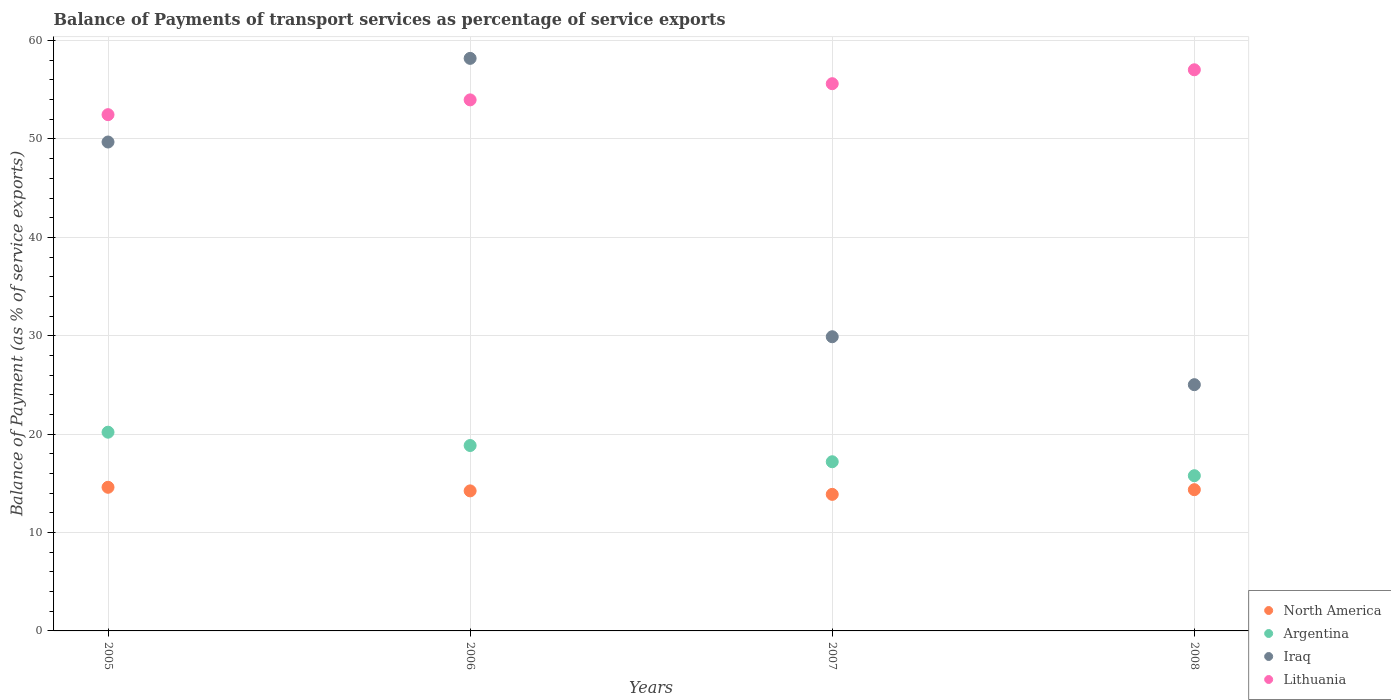What is the balance of payments of transport services in Iraq in 2006?
Keep it short and to the point. 58.19. Across all years, what is the maximum balance of payments of transport services in Iraq?
Offer a terse response. 58.19. Across all years, what is the minimum balance of payments of transport services in Argentina?
Ensure brevity in your answer.  15.78. In which year was the balance of payments of transport services in Argentina maximum?
Ensure brevity in your answer.  2005. In which year was the balance of payments of transport services in Iraq minimum?
Ensure brevity in your answer.  2008. What is the total balance of payments of transport services in North America in the graph?
Make the answer very short. 57.06. What is the difference between the balance of payments of transport services in Iraq in 2005 and that in 2008?
Give a very brief answer. 24.66. What is the difference between the balance of payments of transport services in North America in 2006 and the balance of payments of transport services in Lithuania in 2007?
Your answer should be very brief. -41.38. What is the average balance of payments of transport services in Lithuania per year?
Your answer should be very brief. 54.77. In the year 2007, what is the difference between the balance of payments of transport services in North America and balance of payments of transport services in Iraq?
Provide a short and direct response. -16.02. What is the ratio of the balance of payments of transport services in Argentina in 2006 to that in 2008?
Keep it short and to the point. 1.19. Is the balance of payments of transport services in Argentina in 2005 less than that in 2008?
Ensure brevity in your answer.  No. Is the difference between the balance of payments of transport services in North America in 2005 and 2008 greater than the difference between the balance of payments of transport services in Iraq in 2005 and 2008?
Make the answer very short. No. What is the difference between the highest and the second highest balance of payments of transport services in North America?
Make the answer very short. 0.24. What is the difference between the highest and the lowest balance of payments of transport services in North America?
Provide a short and direct response. 0.72. Is it the case that in every year, the sum of the balance of payments of transport services in Argentina and balance of payments of transport services in Iraq  is greater than the balance of payments of transport services in North America?
Offer a very short reply. Yes. Is the balance of payments of transport services in Iraq strictly greater than the balance of payments of transport services in North America over the years?
Provide a short and direct response. Yes. Is the balance of payments of transport services in Iraq strictly less than the balance of payments of transport services in Lithuania over the years?
Provide a short and direct response. No. Are the values on the major ticks of Y-axis written in scientific E-notation?
Give a very brief answer. No. Does the graph contain any zero values?
Make the answer very short. No. How are the legend labels stacked?
Provide a short and direct response. Vertical. What is the title of the graph?
Offer a very short reply. Balance of Payments of transport services as percentage of service exports. What is the label or title of the X-axis?
Give a very brief answer. Years. What is the label or title of the Y-axis?
Offer a very short reply. Balance of Payment (as % of service exports). What is the Balance of Payment (as % of service exports) in North America in 2005?
Provide a short and direct response. 14.6. What is the Balance of Payment (as % of service exports) of Argentina in 2005?
Your answer should be compact. 20.2. What is the Balance of Payment (as % of service exports) in Iraq in 2005?
Your response must be concise. 49.69. What is the Balance of Payment (as % of service exports) of Lithuania in 2005?
Your response must be concise. 52.47. What is the Balance of Payment (as % of service exports) in North America in 2006?
Your answer should be compact. 14.23. What is the Balance of Payment (as % of service exports) in Argentina in 2006?
Your answer should be very brief. 18.84. What is the Balance of Payment (as % of service exports) in Iraq in 2006?
Your answer should be very brief. 58.19. What is the Balance of Payment (as % of service exports) of Lithuania in 2006?
Keep it short and to the point. 53.97. What is the Balance of Payment (as % of service exports) in North America in 2007?
Provide a short and direct response. 13.88. What is the Balance of Payment (as % of service exports) of Argentina in 2007?
Keep it short and to the point. 17.19. What is the Balance of Payment (as % of service exports) in Iraq in 2007?
Keep it short and to the point. 29.9. What is the Balance of Payment (as % of service exports) of Lithuania in 2007?
Give a very brief answer. 55.62. What is the Balance of Payment (as % of service exports) in North America in 2008?
Offer a terse response. 14.35. What is the Balance of Payment (as % of service exports) in Argentina in 2008?
Offer a terse response. 15.78. What is the Balance of Payment (as % of service exports) of Iraq in 2008?
Provide a succinct answer. 25.03. What is the Balance of Payment (as % of service exports) in Lithuania in 2008?
Give a very brief answer. 57.03. Across all years, what is the maximum Balance of Payment (as % of service exports) of North America?
Make the answer very short. 14.6. Across all years, what is the maximum Balance of Payment (as % of service exports) of Argentina?
Give a very brief answer. 20.2. Across all years, what is the maximum Balance of Payment (as % of service exports) in Iraq?
Your response must be concise. 58.19. Across all years, what is the maximum Balance of Payment (as % of service exports) in Lithuania?
Give a very brief answer. 57.03. Across all years, what is the minimum Balance of Payment (as % of service exports) in North America?
Provide a succinct answer. 13.88. Across all years, what is the minimum Balance of Payment (as % of service exports) in Argentina?
Keep it short and to the point. 15.78. Across all years, what is the minimum Balance of Payment (as % of service exports) in Iraq?
Provide a short and direct response. 25.03. Across all years, what is the minimum Balance of Payment (as % of service exports) in Lithuania?
Offer a very short reply. 52.47. What is the total Balance of Payment (as % of service exports) of North America in the graph?
Your response must be concise. 57.06. What is the total Balance of Payment (as % of service exports) of Argentina in the graph?
Your answer should be very brief. 72.01. What is the total Balance of Payment (as % of service exports) of Iraq in the graph?
Your answer should be very brief. 162.81. What is the total Balance of Payment (as % of service exports) of Lithuania in the graph?
Offer a terse response. 219.09. What is the difference between the Balance of Payment (as % of service exports) in North America in 2005 and that in 2006?
Your answer should be very brief. 0.37. What is the difference between the Balance of Payment (as % of service exports) of Argentina in 2005 and that in 2006?
Provide a short and direct response. 1.35. What is the difference between the Balance of Payment (as % of service exports) in Iraq in 2005 and that in 2006?
Keep it short and to the point. -8.5. What is the difference between the Balance of Payment (as % of service exports) in Lithuania in 2005 and that in 2006?
Make the answer very short. -1.5. What is the difference between the Balance of Payment (as % of service exports) in North America in 2005 and that in 2007?
Offer a very short reply. 0.72. What is the difference between the Balance of Payment (as % of service exports) of Argentina in 2005 and that in 2007?
Provide a succinct answer. 3. What is the difference between the Balance of Payment (as % of service exports) of Iraq in 2005 and that in 2007?
Your answer should be very brief. 19.79. What is the difference between the Balance of Payment (as % of service exports) of Lithuania in 2005 and that in 2007?
Ensure brevity in your answer.  -3.15. What is the difference between the Balance of Payment (as % of service exports) in North America in 2005 and that in 2008?
Make the answer very short. 0.24. What is the difference between the Balance of Payment (as % of service exports) in Argentina in 2005 and that in 2008?
Your answer should be very brief. 4.42. What is the difference between the Balance of Payment (as % of service exports) of Iraq in 2005 and that in 2008?
Provide a short and direct response. 24.66. What is the difference between the Balance of Payment (as % of service exports) in Lithuania in 2005 and that in 2008?
Offer a terse response. -4.56. What is the difference between the Balance of Payment (as % of service exports) of North America in 2006 and that in 2007?
Provide a short and direct response. 0.35. What is the difference between the Balance of Payment (as % of service exports) of Argentina in 2006 and that in 2007?
Your response must be concise. 1.65. What is the difference between the Balance of Payment (as % of service exports) in Iraq in 2006 and that in 2007?
Give a very brief answer. 28.29. What is the difference between the Balance of Payment (as % of service exports) of Lithuania in 2006 and that in 2007?
Provide a succinct answer. -1.64. What is the difference between the Balance of Payment (as % of service exports) in North America in 2006 and that in 2008?
Make the answer very short. -0.12. What is the difference between the Balance of Payment (as % of service exports) in Argentina in 2006 and that in 2008?
Provide a short and direct response. 3.07. What is the difference between the Balance of Payment (as % of service exports) in Iraq in 2006 and that in 2008?
Your answer should be compact. 33.16. What is the difference between the Balance of Payment (as % of service exports) in Lithuania in 2006 and that in 2008?
Keep it short and to the point. -3.06. What is the difference between the Balance of Payment (as % of service exports) in North America in 2007 and that in 2008?
Your answer should be very brief. -0.48. What is the difference between the Balance of Payment (as % of service exports) of Argentina in 2007 and that in 2008?
Your answer should be very brief. 1.42. What is the difference between the Balance of Payment (as % of service exports) in Iraq in 2007 and that in 2008?
Your answer should be very brief. 4.87. What is the difference between the Balance of Payment (as % of service exports) of Lithuania in 2007 and that in 2008?
Provide a succinct answer. -1.41. What is the difference between the Balance of Payment (as % of service exports) of North America in 2005 and the Balance of Payment (as % of service exports) of Argentina in 2006?
Offer a terse response. -4.24. What is the difference between the Balance of Payment (as % of service exports) in North America in 2005 and the Balance of Payment (as % of service exports) in Iraq in 2006?
Ensure brevity in your answer.  -43.59. What is the difference between the Balance of Payment (as % of service exports) in North America in 2005 and the Balance of Payment (as % of service exports) in Lithuania in 2006?
Make the answer very short. -39.37. What is the difference between the Balance of Payment (as % of service exports) of Argentina in 2005 and the Balance of Payment (as % of service exports) of Iraq in 2006?
Offer a very short reply. -37.99. What is the difference between the Balance of Payment (as % of service exports) of Argentina in 2005 and the Balance of Payment (as % of service exports) of Lithuania in 2006?
Offer a very short reply. -33.77. What is the difference between the Balance of Payment (as % of service exports) of Iraq in 2005 and the Balance of Payment (as % of service exports) of Lithuania in 2006?
Your answer should be very brief. -4.28. What is the difference between the Balance of Payment (as % of service exports) of North America in 2005 and the Balance of Payment (as % of service exports) of Argentina in 2007?
Give a very brief answer. -2.6. What is the difference between the Balance of Payment (as % of service exports) in North America in 2005 and the Balance of Payment (as % of service exports) in Iraq in 2007?
Keep it short and to the point. -15.3. What is the difference between the Balance of Payment (as % of service exports) of North America in 2005 and the Balance of Payment (as % of service exports) of Lithuania in 2007?
Provide a succinct answer. -41.02. What is the difference between the Balance of Payment (as % of service exports) in Argentina in 2005 and the Balance of Payment (as % of service exports) in Iraq in 2007?
Make the answer very short. -9.7. What is the difference between the Balance of Payment (as % of service exports) of Argentina in 2005 and the Balance of Payment (as % of service exports) of Lithuania in 2007?
Provide a short and direct response. -35.42. What is the difference between the Balance of Payment (as % of service exports) of Iraq in 2005 and the Balance of Payment (as % of service exports) of Lithuania in 2007?
Offer a very short reply. -5.93. What is the difference between the Balance of Payment (as % of service exports) in North America in 2005 and the Balance of Payment (as % of service exports) in Argentina in 2008?
Offer a terse response. -1.18. What is the difference between the Balance of Payment (as % of service exports) of North America in 2005 and the Balance of Payment (as % of service exports) of Iraq in 2008?
Provide a succinct answer. -10.43. What is the difference between the Balance of Payment (as % of service exports) of North America in 2005 and the Balance of Payment (as % of service exports) of Lithuania in 2008?
Keep it short and to the point. -42.43. What is the difference between the Balance of Payment (as % of service exports) in Argentina in 2005 and the Balance of Payment (as % of service exports) in Iraq in 2008?
Your answer should be compact. -4.83. What is the difference between the Balance of Payment (as % of service exports) in Argentina in 2005 and the Balance of Payment (as % of service exports) in Lithuania in 2008?
Offer a terse response. -36.83. What is the difference between the Balance of Payment (as % of service exports) in Iraq in 2005 and the Balance of Payment (as % of service exports) in Lithuania in 2008?
Your answer should be compact. -7.34. What is the difference between the Balance of Payment (as % of service exports) of North America in 2006 and the Balance of Payment (as % of service exports) of Argentina in 2007?
Your response must be concise. -2.96. What is the difference between the Balance of Payment (as % of service exports) of North America in 2006 and the Balance of Payment (as % of service exports) of Iraq in 2007?
Offer a terse response. -15.67. What is the difference between the Balance of Payment (as % of service exports) of North America in 2006 and the Balance of Payment (as % of service exports) of Lithuania in 2007?
Keep it short and to the point. -41.38. What is the difference between the Balance of Payment (as % of service exports) in Argentina in 2006 and the Balance of Payment (as % of service exports) in Iraq in 2007?
Your answer should be compact. -11.06. What is the difference between the Balance of Payment (as % of service exports) of Argentina in 2006 and the Balance of Payment (as % of service exports) of Lithuania in 2007?
Make the answer very short. -36.77. What is the difference between the Balance of Payment (as % of service exports) of Iraq in 2006 and the Balance of Payment (as % of service exports) of Lithuania in 2007?
Offer a terse response. 2.57. What is the difference between the Balance of Payment (as % of service exports) of North America in 2006 and the Balance of Payment (as % of service exports) of Argentina in 2008?
Keep it short and to the point. -1.54. What is the difference between the Balance of Payment (as % of service exports) of North America in 2006 and the Balance of Payment (as % of service exports) of Iraq in 2008?
Offer a very short reply. -10.79. What is the difference between the Balance of Payment (as % of service exports) in North America in 2006 and the Balance of Payment (as % of service exports) in Lithuania in 2008?
Give a very brief answer. -42.8. What is the difference between the Balance of Payment (as % of service exports) of Argentina in 2006 and the Balance of Payment (as % of service exports) of Iraq in 2008?
Give a very brief answer. -6.18. What is the difference between the Balance of Payment (as % of service exports) of Argentina in 2006 and the Balance of Payment (as % of service exports) of Lithuania in 2008?
Offer a terse response. -38.19. What is the difference between the Balance of Payment (as % of service exports) of Iraq in 2006 and the Balance of Payment (as % of service exports) of Lithuania in 2008?
Offer a very short reply. 1.16. What is the difference between the Balance of Payment (as % of service exports) in North America in 2007 and the Balance of Payment (as % of service exports) in Argentina in 2008?
Keep it short and to the point. -1.9. What is the difference between the Balance of Payment (as % of service exports) of North America in 2007 and the Balance of Payment (as % of service exports) of Iraq in 2008?
Offer a very short reply. -11.15. What is the difference between the Balance of Payment (as % of service exports) in North America in 2007 and the Balance of Payment (as % of service exports) in Lithuania in 2008?
Keep it short and to the point. -43.15. What is the difference between the Balance of Payment (as % of service exports) of Argentina in 2007 and the Balance of Payment (as % of service exports) of Iraq in 2008?
Provide a short and direct response. -7.83. What is the difference between the Balance of Payment (as % of service exports) of Argentina in 2007 and the Balance of Payment (as % of service exports) of Lithuania in 2008?
Your answer should be very brief. -39.84. What is the difference between the Balance of Payment (as % of service exports) in Iraq in 2007 and the Balance of Payment (as % of service exports) in Lithuania in 2008?
Offer a very short reply. -27.13. What is the average Balance of Payment (as % of service exports) of North America per year?
Provide a succinct answer. 14.27. What is the average Balance of Payment (as % of service exports) of Argentina per year?
Offer a terse response. 18. What is the average Balance of Payment (as % of service exports) in Iraq per year?
Offer a terse response. 40.7. What is the average Balance of Payment (as % of service exports) of Lithuania per year?
Give a very brief answer. 54.77. In the year 2005, what is the difference between the Balance of Payment (as % of service exports) in North America and Balance of Payment (as % of service exports) in Argentina?
Ensure brevity in your answer.  -5.6. In the year 2005, what is the difference between the Balance of Payment (as % of service exports) in North America and Balance of Payment (as % of service exports) in Iraq?
Your answer should be compact. -35.09. In the year 2005, what is the difference between the Balance of Payment (as % of service exports) in North America and Balance of Payment (as % of service exports) in Lithuania?
Offer a terse response. -37.87. In the year 2005, what is the difference between the Balance of Payment (as % of service exports) in Argentina and Balance of Payment (as % of service exports) in Iraq?
Provide a short and direct response. -29.49. In the year 2005, what is the difference between the Balance of Payment (as % of service exports) in Argentina and Balance of Payment (as % of service exports) in Lithuania?
Your response must be concise. -32.27. In the year 2005, what is the difference between the Balance of Payment (as % of service exports) of Iraq and Balance of Payment (as % of service exports) of Lithuania?
Your response must be concise. -2.78. In the year 2006, what is the difference between the Balance of Payment (as % of service exports) of North America and Balance of Payment (as % of service exports) of Argentina?
Your response must be concise. -4.61. In the year 2006, what is the difference between the Balance of Payment (as % of service exports) in North America and Balance of Payment (as % of service exports) in Iraq?
Offer a very short reply. -43.96. In the year 2006, what is the difference between the Balance of Payment (as % of service exports) in North America and Balance of Payment (as % of service exports) in Lithuania?
Offer a terse response. -39.74. In the year 2006, what is the difference between the Balance of Payment (as % of service exports) of Argentina and Balance of Payment (as % of service exports) of Iraq?
Keep it short and to the point. -39.35. In the year 2006, what is the difference between the Balance of Payment (as % of service exports) of Argentina and Balance of Payment (as % of service exports) of Lithuania?
Provide a succinct answer. -35.13. In the year 2006, what is the difference between the Balance of Payment (as % of service exports) of Iraq and Balance of Payment (as % of service exports) of Lithuania?
Give a very brief answer. 4.22. In the year 2007, what is the difference between the Balance of Payment (as % of service exports) in North America and Balance of Payment (as % of service exports) in Argentina?
Keep it short and to the point. -3.32. In the year 2007, what is the difference between the Balance of Payment (as % of service exports) in North America and Balance of Payment (as % of service exports) in Iraq?
Offer a terse response. -16.02. In the year 2007, what is the difference between the Balance of Payment (as % of service exports) of North America and Balance of Payment (as % of service exports) of Lithuania?
Ensure brevity in your answer.  -41.74. In the year 2007, what is the difference between the Balance of Payment (as % of service exports) of Argentina and Balance of Payment (as % of service exports) of Iraq?
Your answer should be very brief. -12.71. In the year 2007, what is the difference between the Balance of Payment (as % of service exports) of Argentina and Balance of Payment (as % of service exports) of Lithuania?
Make the answer very short. -38.42. In the year 2007, what is the difference between the Balance of Payment (as % of service exports) of Iraq and Balance of Payment (as % of service exports) of Lithuania?
Make the answer very short. -25.72. In the year 2008, what is the difference between the Balance of Payment (as % of service exports) in North America and Balance of Payment (as % of service exports) in Argentina?
Provide a short and direct response. -1.42. In the year 2008, what is the difference between the Balance of Payment (as % of service exports) of North America and Balance of Payment (as % of service exports) of Iraq?
Your answer should be very brief. -10.67. In the year 2008, what is the difference between the Balance of Payment (as % of service exports) of North America and Balance of Payment (as % of service exports) of Lithuania?
Ensure brevity in your answer.  -42.68. In the year 2008, what is the difference between the Balance of Payment (as % of service exports) of Argentina and Balance of Payment (as % of service exports) of Iraq?
Ensure brevity in your answer.  -9.25. In the year 2008, what is the difference between the Balance of Payment (as % of service exports) in Argentina and Balance of Payment (as % of service exports) in Lithuania?
Your answer should be very brief. -41.26. In the year 2008, what is the difference between the Balance of Payment (as % of service exports) in Iraq and Balance of Payment (as % of service exports) in Lithuania?
Offer a very short reply. -32.01. What is the ratio of the Balance of Payment (as % of service exports) in North America in 2005 to that in 2006?
Provide a succinct answer. 1.03. What is the ratio of the Balance of Payment (as % of service exports) in Argentina in 2005 to that in 2006?
Provide a succinct answer. 1.07. What is the ratio of the Balance of Payment (as % of service exports) in Iraq in 2005 to that in 2006?
Your response must be concise. 0.85. What is the ratio of the Balance of Payment (as % of service exports) in Lithuania in 2005 to that in 2006?
Provide a succinct answer. 0.97. What is the ratio of the Balance of Payment (as % of service exports) of North America in 2005 to that in 2007?
Provide a succinct answer. 1.05. What is the ratio of the Balance of Payment (as % of service exports) in Argentina in 2005 to that in 2007?
Provide a short and direct response. 1.17. What is the ratio of the Balance of Payment (as % of service exports) of Iraq in 2005 to that in 2007?
Provide a succinct answer. 1.66. What is the ratio of the Balance of Payment (as % of service exports) in Lithuania in 2005 to that in 2007?
Provide a short and direct response. 0.94. What is the ratio of the Balance of Payment (as % of service exports) of North America in 2005 to that in 2008?
Provide a short and direct response. 1.02. What is the ratio of the Balance of Payment (as % of service exports) in Argentina in 2005 to that in 2008?
Provide a succinct answer. 1.28. What is the ratio of the Balance of Payment (as % of service exports) of Iraq in 2005 to that in 2008?
Keep it short and to the point. 1.99. What is the ratio of the Balance of Payment (as % of service exports) in North America in 2006 to that in 2007?
Provide a succinct answer. 1.03. What is the ratio of the Balance of Payment (as % of service exports) in Argentina in 2006 to that in 2007?
Provide a short and direct response. 1.1. What is the ratio of the Balance of Payment (as % of service exports) in Iraq in 2006 to that in 2007?
Provide a succinct answer. 1.95. What is the ratio of the Balance of Payment (as % of service exports) in Lithuania in 2006 to that in 2007?
Offer a terse response. 0.97. What is the ratio of the Balance of Payment (as % of service exports) in Argentina in 2006 to that in 2008?
Provide a succinct answer. 1.19. What is the ratio of the Balance of Payment (as % of service exports) of Iraq in 2006 to that in 2008?
Provide a succinct answer. 2.33. What is the ratio of the Balance of Payment (as % of service exports) in Lithuania in 2006 to that in 2008?
Keep it short and to the point. 0.95. What is the ratio of the Balance of Payment (as % of service exports) of North America in 2007 to that in 2008?
Keep it short and to the point. 0.97. What is the ratio of the Balance of Payment (as % of service exports) of Argentina in 2007 to that in 2008?
Provide a short and direct response. 1.09. What is the ratio of the Balance of Payment (as % of service exports) of Iraq in 2007 to that in 2008?
Give a very brief answer. 1.19. What is the ratio of the Balance of Payment (as % of service exports) in Lithuania in 2007 to that in 2008?
Your answer should be very brief. 0.98. What is the difference between the highest and the second highest Balance of Payment (as % of service exports) in North America?
Your answer should be very brief. 0.24. What is the difference between the highest and the second highest Balance of Payment (as % of service exports) of Argentina?
Provide a short and direct response. 1.35. What is the difference between the highest and the second highest Balance of Payment (as % of service exports) in Iraq?
Give a very brief answer. 8.5. What is the difference between the highest and the second highest Balance of Payment (as % of service exports) in Lithuania?
Offer a very short reply. 1.41. What is the difference between the highest and the lowest Balance of Payment (as % of service exports) in North America?
Your answer should be compact. 0.72. What is the difference between the highest and the lowest Balance of Payment (as % of service exports) in Argentina?
Provide a succinct answer. 4.42. What is the difference between the highest and the lowest Balance of Payment (as % of service exports) of Iraq?
Your answer should be very brief. 33.16. What is the difference between the highest and the lowest Balance of Payment (as % of service exports) of Lithuania?
Your response must be concise. 4.56. 